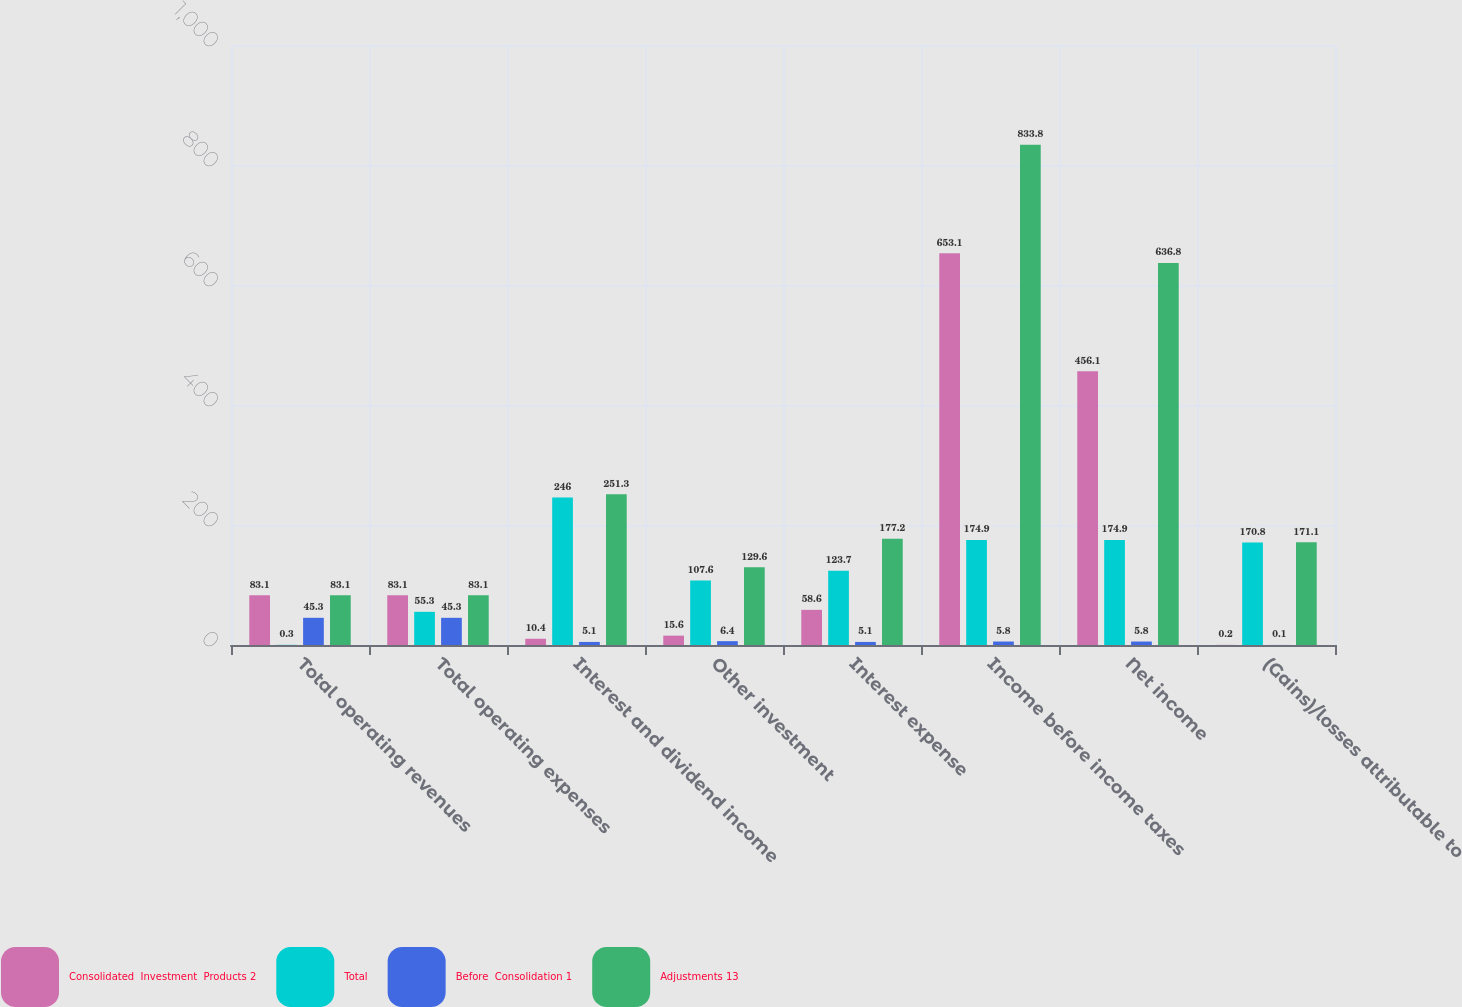Convert chart to OTSL. <chart><loc_0><loc_0><loc_500><loc_500><stacked_bar_chart><ecel><fcel>Total operating revenues<fcel>Total operating expenses<fcel>Interest and dividend income<fcel>Other investment<fcel>Interest expense<fcel>Income before income taxes<fcel>Net income<fcel>(Gains)/losses attributable to<nl><fcel>Consolidated  Investment  Products 2<fcel>83.1<fcel>83.1<fcel>10.4<fcel>15.6<fcel>58.6<fcel>653.1<fcel>456.1<fcel>0.2<nl><fcel>Total<fcel>0.3<fcel>55.3<fcel>246<fcel>107.6<fcel>123.7<fcel>174.9<fcel>174.9<fcel>170.8<nl><fcel>Before  Consolidation 1<fcel>45.3<fcel>45.3<fcel>5.1<fcel>6.4<fcel>5.1<fcel>5.8<fcel>5.8<fcel>0.1<nl><fcel>Adjustments 13<fcel>83.1<fcel>83.1<fcel>251.3<fcel>129.6<fcel>177.2<fcel>833.8<fcel>636.8<fcel>171.1<nl></chart> 